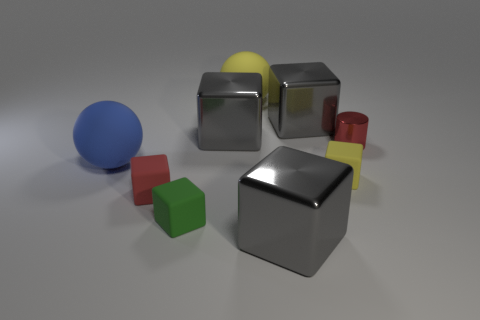Subtract all gray blocks. How many were subtracted if there are1gray blocks left? 2 Subtract all yellow blocks. How many blocks are left? 5 Add 1 tiny red things. How many objects exist? 10 Subtract all yellow cylinders. How many gray blocks are left? 3 Subtract all cylinders. How many objects are left? 8 Subtract 1 spheres. How many spheres are left? 1 Subtract all brown cylinders. Subtract all cyan balls. How many cylinders are left? 1 Subtract all matte spheres. Subtract all small gray matte cubes. How many objects are left? 7 Add 4 big blocks. How many big blocks are left? 7 Add 5 small red things. How many small red things exist? 7 